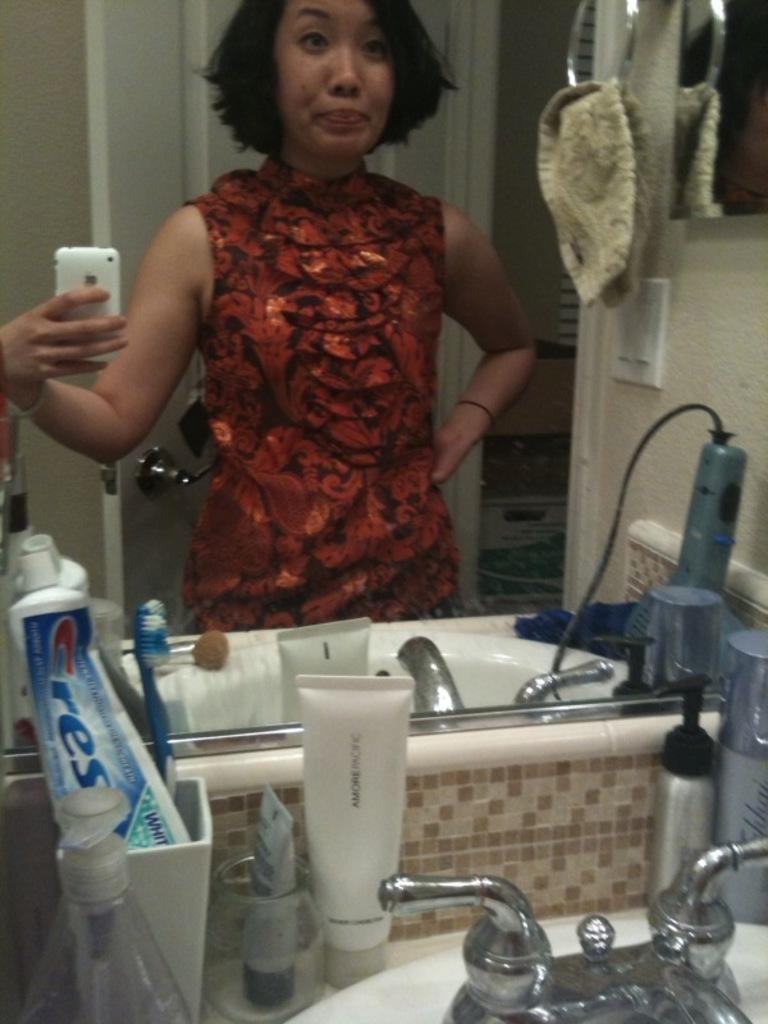<image>
Offer a succinct explanation of the picture presented. A women takes a selfie in front of her tube of Crest toothpaste. 